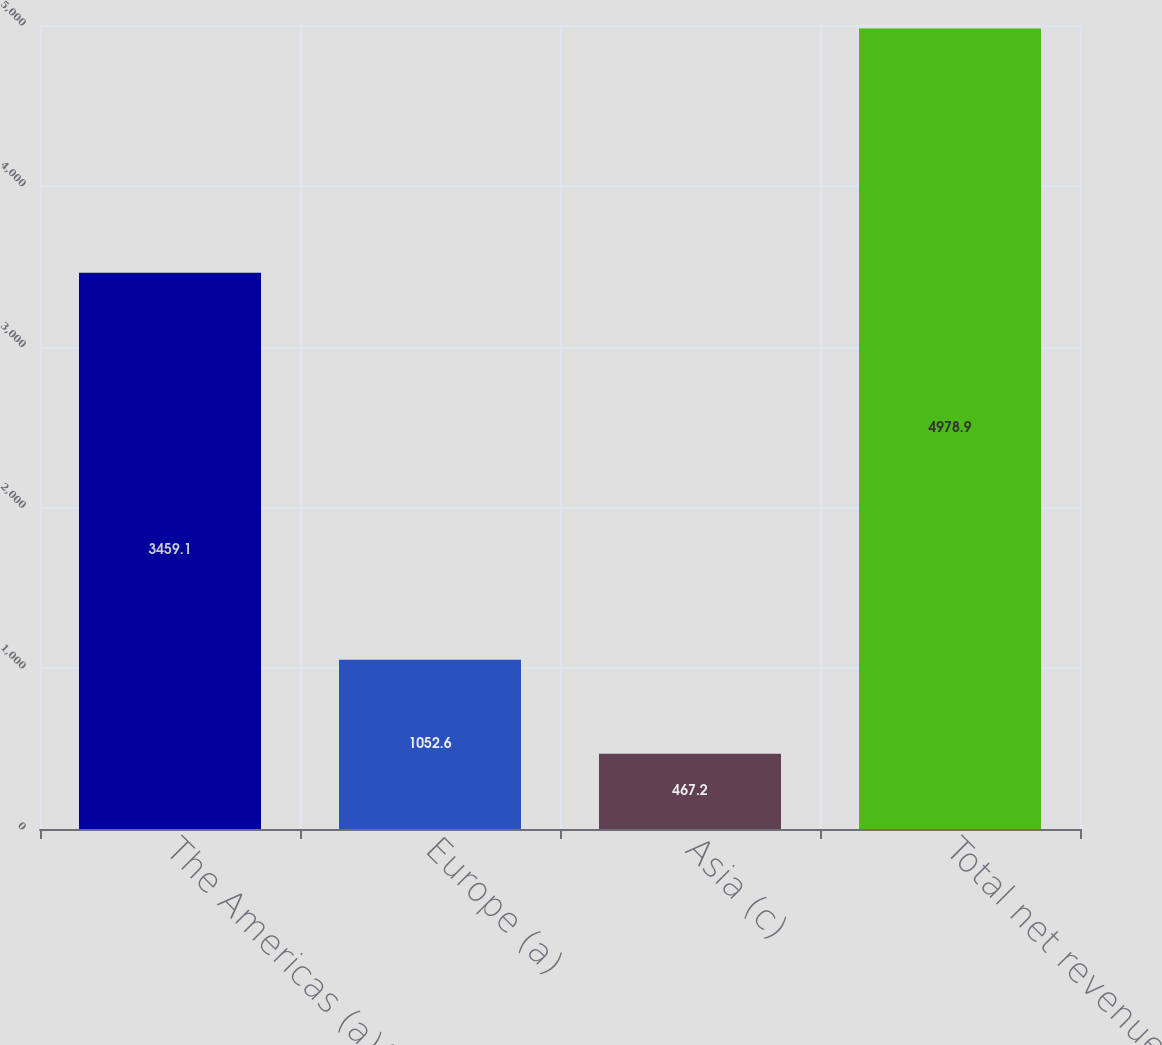Convert chart. <chart><loc_0><loc_0><loc_500><loc_500><bar_chart><fcel>The Americas (a)(b)<fcel>Europe (a)<fcel>Asia (c)<fcel>Total net revenues<nl><fcel>3459.1<fcel>1052.6<fcel>467.2<fcel>4978.9<nl></chart> 